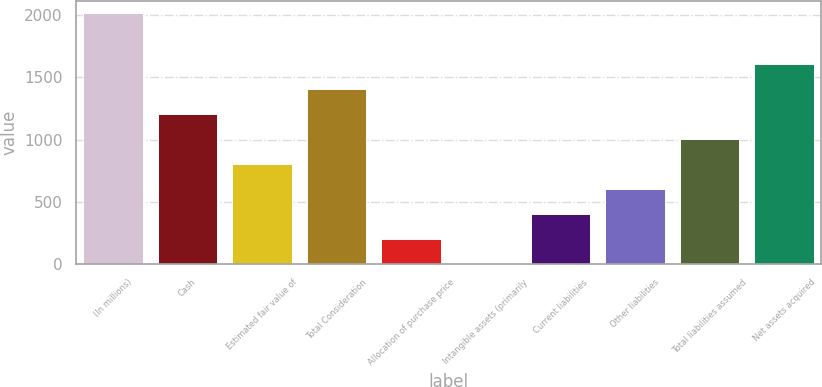<chart> <loc_0><loc_0><loc_500><loc_500><bar_chart><fcel>(In millions)<fcel>Cash<fcel>Estimated fair value of<fcel>Total Consideration<fcel>Allocation of purchase price<fcel>Intangible assets (primarily<fcel>Current liabilities<fcel>Other liabilities<fcel>Total liabilities assumed<fcel>Net assets acquired<nl><fcel>2013<fcel>1209<fcel>807<fcel>1410<fcel>204<fcel>3<fcel>405<fcel>606<fcel>1008<fcel>1611<nl></chart> 